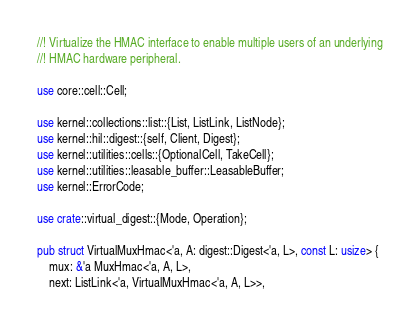Convert code to text. <code><loc_0><loc_0><loc_500><loc_500><_Rust_>//! Virtualize the HMAC interface to enable multiple users of an underlying
//! HMAC hardware peripheral.

use core::cell::Cell;

use kernel::collections::list::{List, ListLink, ListNode};
use kernel::hil::digest::{self, Client, Digest};
use kernel::utilities::cells::{OptionalCell, TakeCell};
use kernel::utilities::leasable_buffer::LeasableBuffer;
use kernel::ErrorCode;

use crate::virtual_digest::{Mode, Operation};

pub struct VirtualMuxHmac<'a, A: digest::Digest<'a, L>, const L: usize> {
    mux: &'a MuxHmac<'a, A, L>,
    next: ListLink<'a, VirtualMuxHmac<'a, A, L>>,</code> 